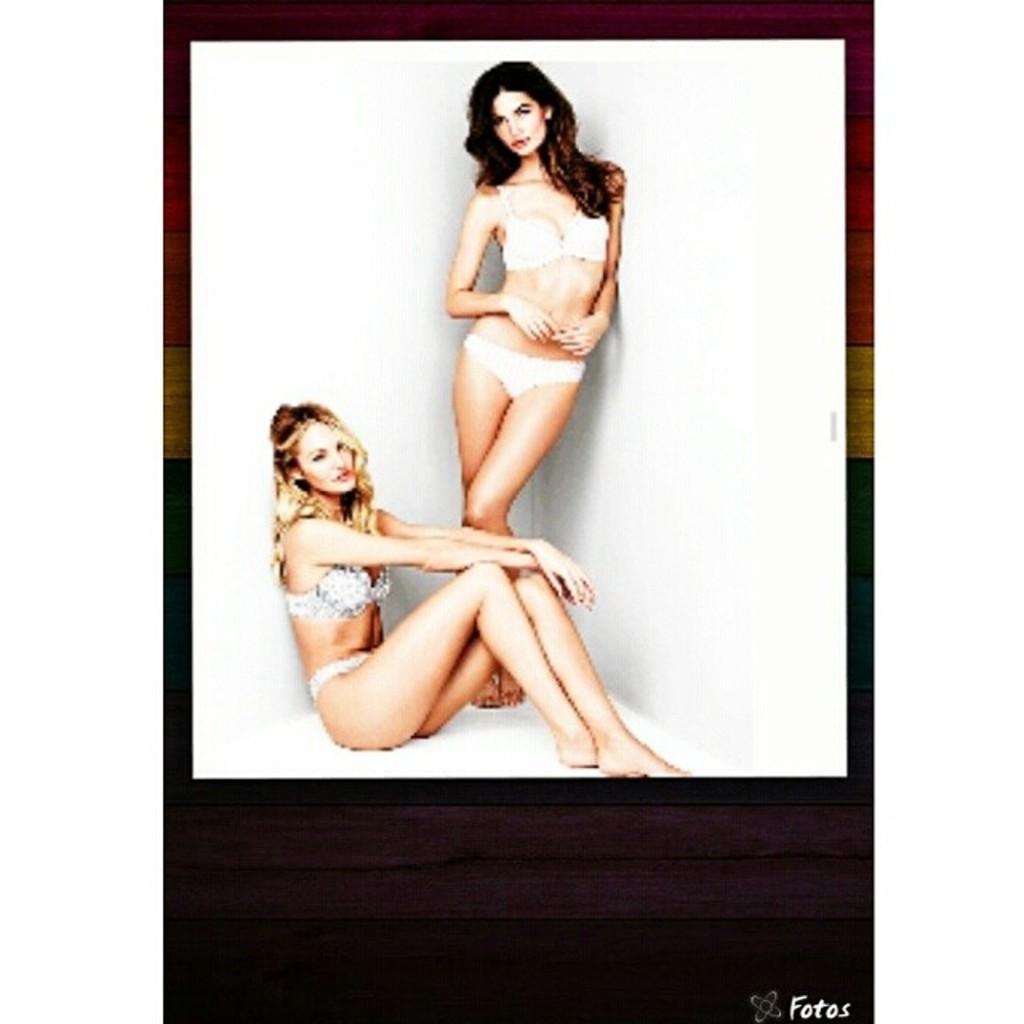In one or two sentences, can you explain what this image depicts? Here, we can see two women, there is a white color wall. 